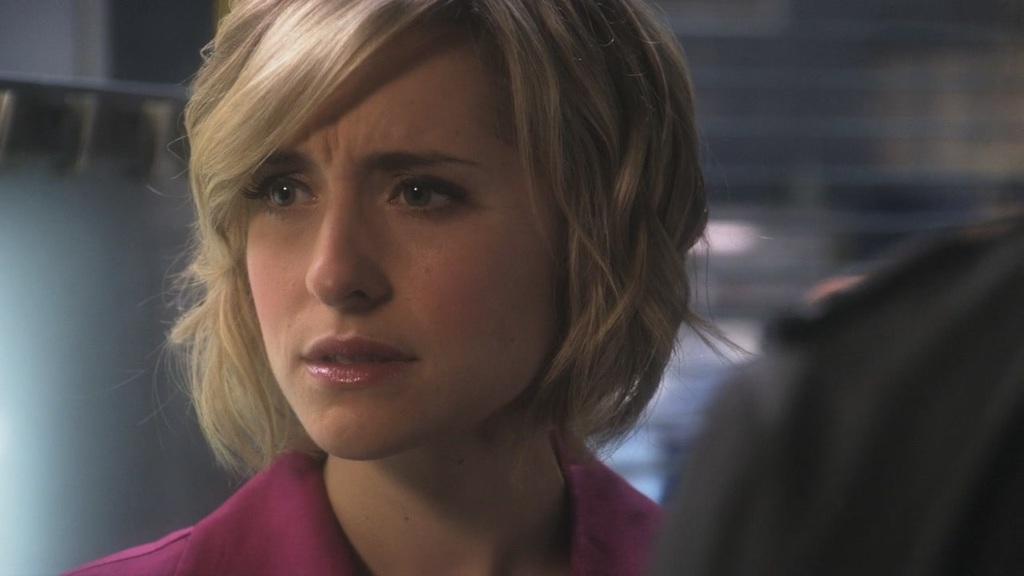Can you describe this image briefly? In this image I can see a woman is looking at the left side. On the right side, it seems to be a person. The background is blurred. 